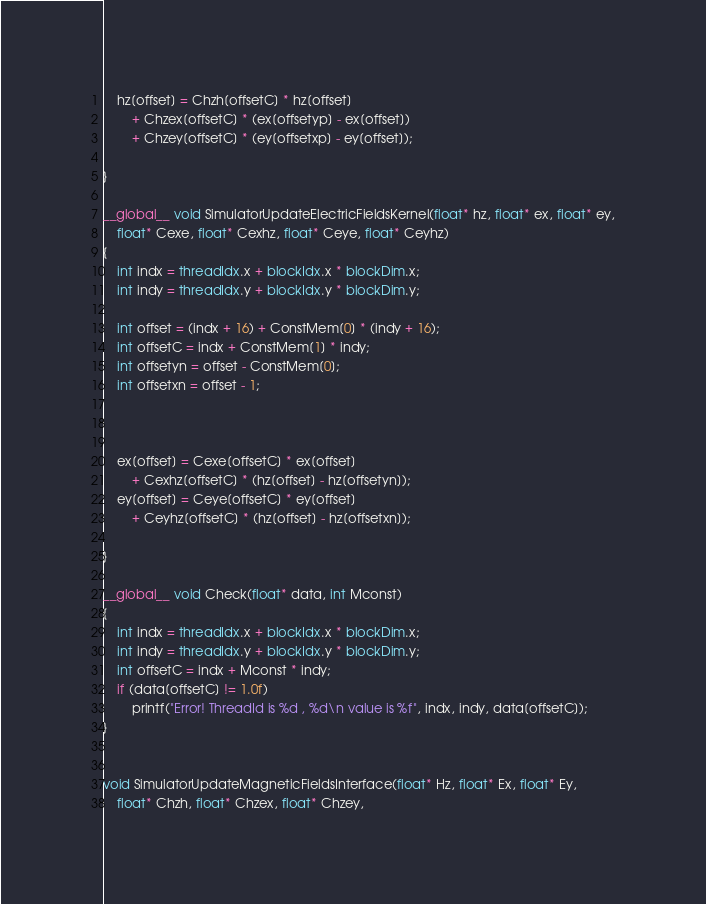Convert code to text. <code><loc_0><loc_0><loc_500><loc_500><_Cuda_>    hz[offset] = Chzh[offsetC] * hz[offset] 
        + Chzex[offsetC] * (ex[offsetyp] - ex[offset]) 
        + Chzey[offsetC] * (ey[offsetxp] - ey[offset]);

}

__global__ void SimulatorUpdateElectricFieldsKernel(float* hz, float* ex, float* ey,
    float* Cexe, float* Cexhz, float* Ceye, float* Ceyhz)
{
    int indx = threadIdx.x + blockIdx.x * blockDim.x;
    int indy = threadIdx.y + blockIdx.y * blockDim.y;
    
    int offset = (indx + 16) + ConstMem[0] * (indy + 16);
    int offsetC = indx + ConstMem[1] * indy;
    int offsetyn = offset - ConstMem[0];
    int offsetxn = offset - 1;


   
    ex[offset] = Cexe[offsetC] * ex[offset]
        + Cexhz[offsetC] * (hz[offset] - hz[offsetyn]);
    ey[offset] = Ceye[offsetC] * ey[offset]
        + Ceyhz[offsetC] * (hz[offset] - hz[offsetxn]);

}

__global__ void Check(float* data, int Mconst)
{
    int indx = threadIdx.x + blockIdx.x * blockDim.x;
    int indy = threadIdx.y + blockIdx.y * blockDim.y;
    int offsetC = indx + Mconst * indy;
    if (data[offsetC] != 1.0f)
        printf("Error! ThreadId is %d , %d\n value is %f", indx, indy, data[offsetC]);
}


void SimulatorUpdateMagneticFieldsInterface(float* Hz, float* Ex, float* Ey,
    float* Chzh, float* Chzex, float* Chzey,</code> 